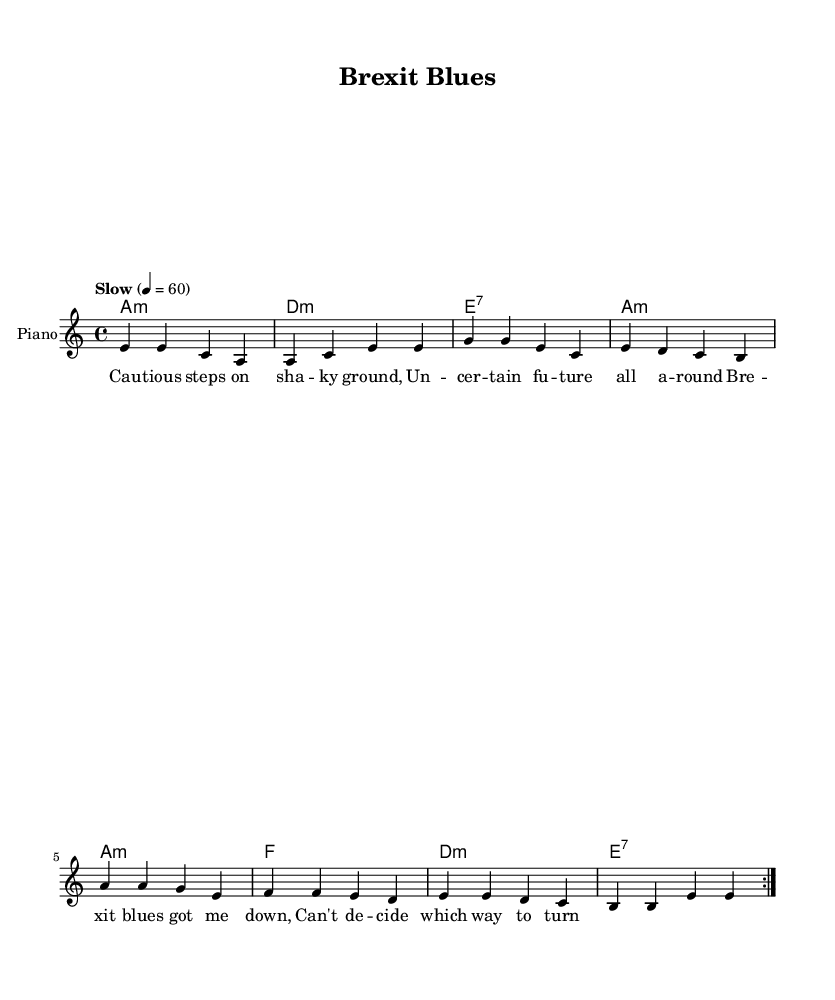What is the key signature of this music? The key signature is indicated on the staff before the first note. In this case, the key signature corresponds to A minor, which has no sharps or flats.
Answer: A minor What is the time signature of this music? The time signature is shown as a fraction at the beginning of the piece, specifying the number of beats per measure. Here, it indicates 4 beats in a measure, which is represented as 4/4.
Answer: 4/4 What is the tempo marking of this music? The tempo is notated above the staff, in this case, "Slow" along with a metronome marking of 60 beats per minute, indicating the intended speed of the music.
Answer: Slow 60 How many measures are in the repeated section of the melody? By counting the measures in the repeated section marked by "repeat volta 2," we see that there are eight measures in total (4 measures in the first half and 4 in the second).
Answer: 8 What type of chord is the first harmony played? The first chord in the chord progression is labeled "a1:m" which indicates that it is an A minor chord as denoted by the "m."
Answer: A minor Which line from the lyrics reflects cautious decision-making? The lyric "Cau -- tious steps on sha -- ky ground," directly references the theme of being cautious and careful in uncertain situations, illustrating the concept of decision-making during difficult times.
Answer: Cautious steps How does the chord progression relate to the lyrics? The chord progression underpins the lyrical content, with the A minor chord reflecting the melancholic nature typical of blues music and supporting the emotional context found in the lyrics about uncertainty and cautiousness.
Answer: Reflects melancholy 